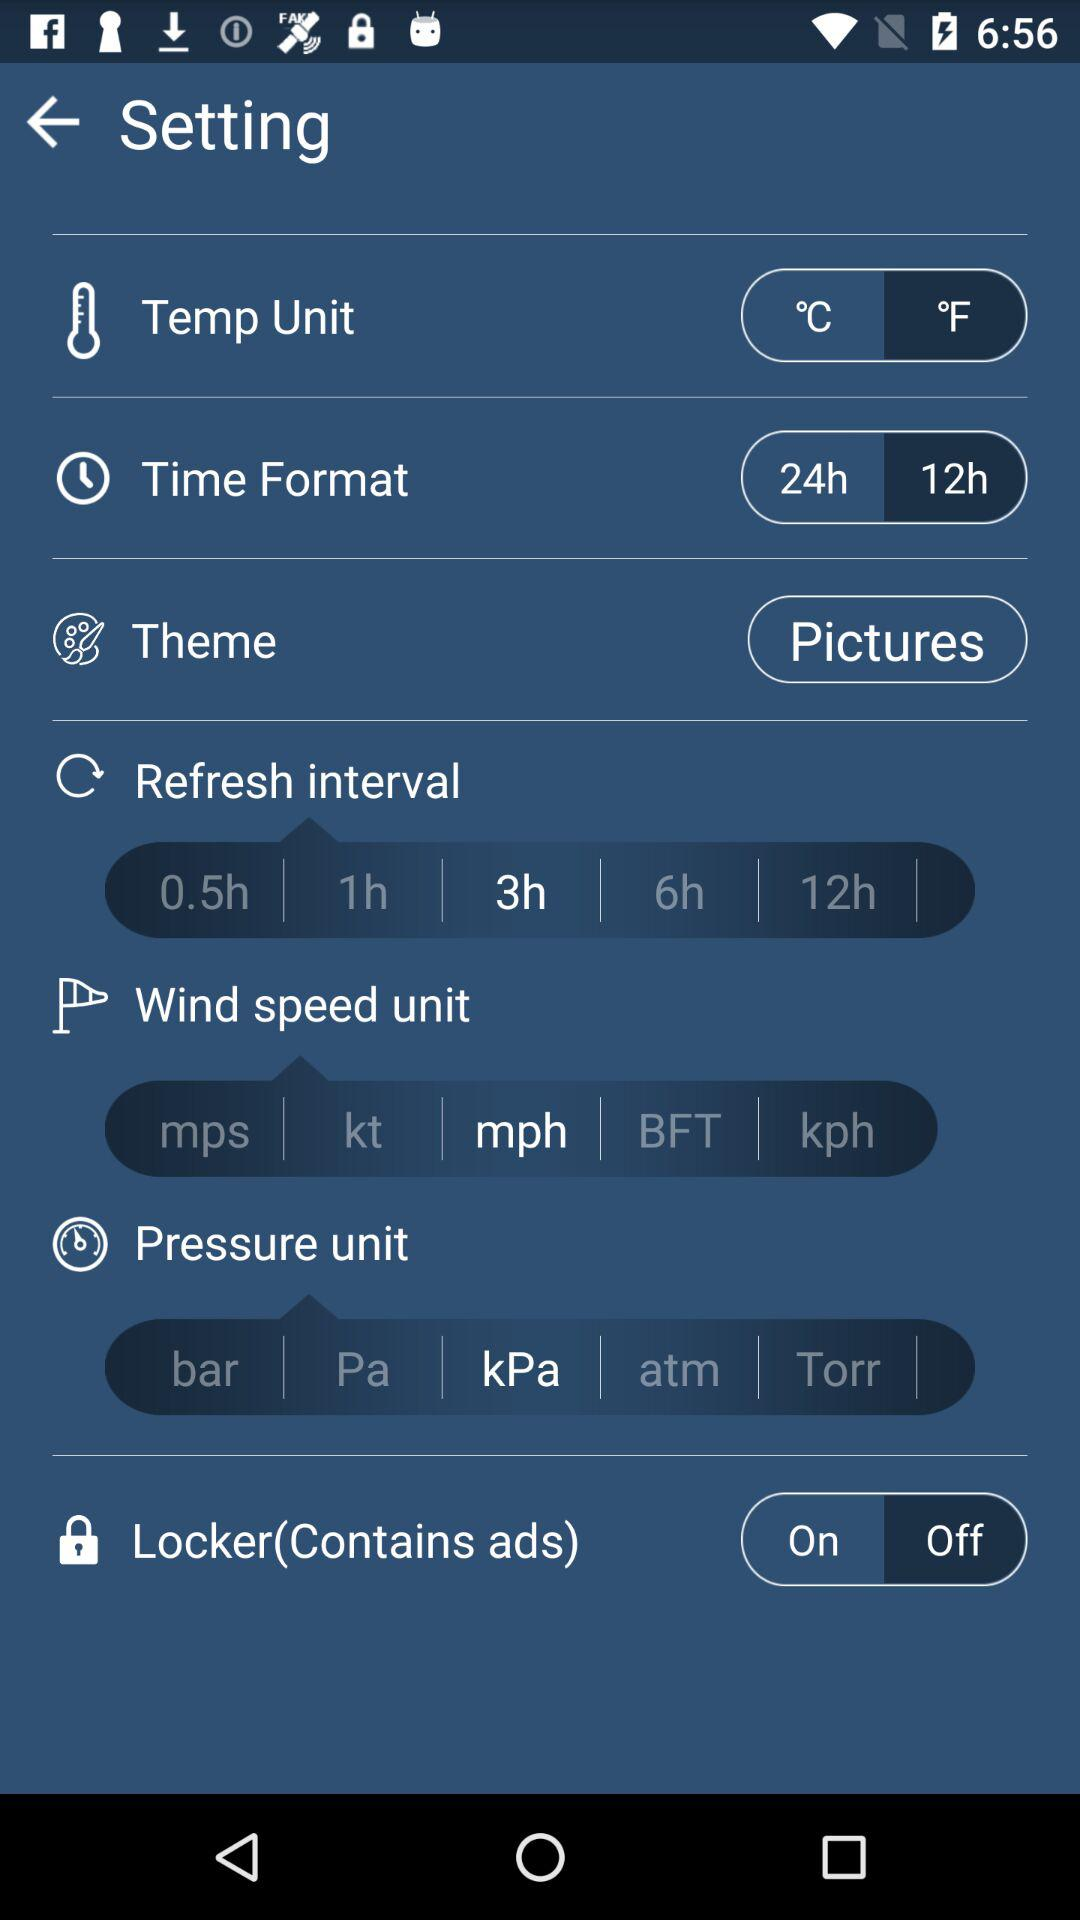What is the wind speed unit? The wind speed unit is mph. 